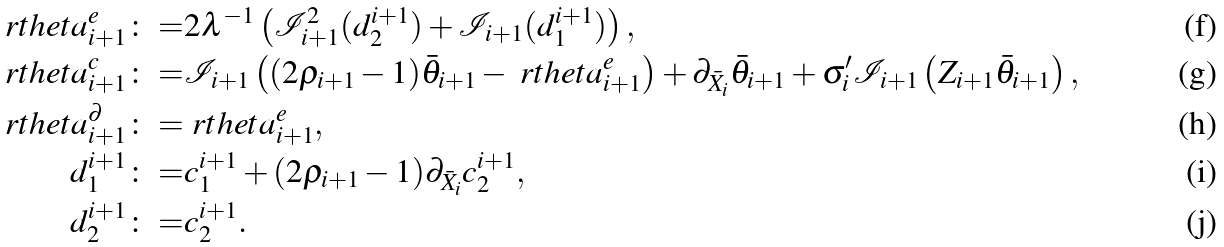<formula> <loc_0><loc_0><loc_500><loc_500>\ r t h e t a ^ { e } _ { i + 1 } \colon = & 2 \lambda ^ { - 1 } \left ( { \mathcal { I } } _ { i + 1 } ^ { 2 } ( d _ { 2 } ^ { i + 1 } ) + { \mathcal { I } } _ { i + 1 } ( d ^ { i + 1 } _ { 1 } ) \right ) , \\ { \ r t h e t a } _ { i + 1 } ^ { c } \colon = & { { \mathcal { I } } } _ { i + 1 } \left ( ( 2 \rho _ { i + 1 } - 1 ) \bar { \theta } _ { i + 1 } - \ r t h e t a ^ { e } _ { i + 1 } \right ) + \partial _ { \bar { X } _ { i } } \bar { \theta } _ { i + 1 } + \sigma ^ { \prime } _ { i } { { \mathcal { I } } } _ { i + 1 } \left ( Z _ { i + 1 } \bar { \theta } _ { i + 1 } \right ) , \\ { \ r t h e t a } _ { i + 1 } ^ { \partial } \colon = & \ r t h e t a ^ { e } _ { i + 1 } , \\ d _ { 1 } ^ { i + 1 } \colon = & c _ { 1 } ^ { i + 1 } + ( 2 \rho _ { i + 1 } - 1 ) \partial _ { \bar { X } _ { i } } c _ { 2 } ^ { i + 1 } , \\ d _ { 2 } ^ { i + 1 } \colon = & c _ { 2 } ^ { i + 1 } .</formula> 